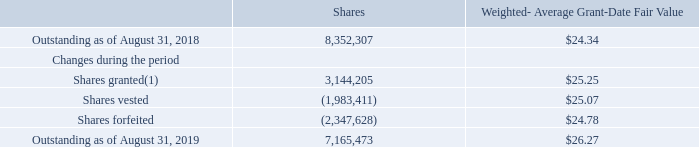Restricted Stock Units
Certain key employees have been granted time-based, performance-based and market-based restricted stock units. The time-based restricted stock units granted generally vest on a graded vesting schedule over three years. The performance-based restricted stock units generally vest on a cliff vesting schedule over three years and up to a maximum of 150%, depending on the specified performance condition and the level of achievement obtained. The performance-based restricted stock units have a vesting condition that is based upon the Company’s cumulative adjusted core earnings per share during the performance period. The market-based restricted stock units generally vest on a cliff vesting schedule over three years and up to a maximum of 200%, depending on the specified performance condition and the level of achievement obtained. The market-based restricted stock units have a vesting condition that is tied to the Company’s total shareholder return based on the Company’s stock performance in relation to the companies in the Standard and Poor’s (S&P) Super Composite Technology Hardware and Equipment Index excluding the Company.
On October 6, 2017, the Company’s Compensation Committee approved the modification of vesting criteria for certain performance-based restricted stock units granted in fiscal year 2015. As a result of the modification, 0.8 million awards vested during the first quarter of fiscal year 2018, which resulted in approximately $24.9 million of stock-based compensation expense recognized.
The following table summarizes restricted stock units activity from August 31, 2018 through August 31, 2019:
(1) For those shares granted that are based on the achievement of certain performance criteria, the amount represents the maximum number of shares that can vest. During the fiscal year ended August 31, 2019, the Company awarded approximately 1.6 million time-based restricted stock units, 0.4 million performance based restricted stock units and 0.4 million market-based restricted stock units based on target performance criteria.
Which dates does the table provide data for outstanding restricted stock units for? August 31, 2018, august 31, 2019. What does the amount for shares granted that are based on the achievement of certain performance criteria represent? The maximum number of shares that can vest. What was the amount of shares forfeited? (2,347,628). What was the average fair weighted average grant-date fair value between shares granted, vested and forfeited? ($25.25+$25.07+$24.78)/(2019-2018+2)
Answer: 25.03. What was the change in the weighted average grant-date fair value between 2018 and 2019? $26.27-$24.34
Answer: 1.93. What was the percentage change in the number of shares between 2018 and 2019?
Answer scale should be: percent. (7,165,473-8,352,307)/8,352,307
Answer: -14.21. 